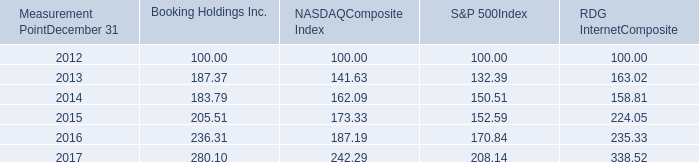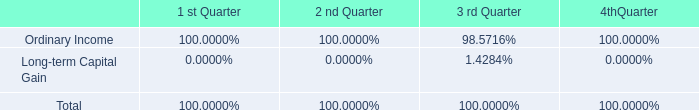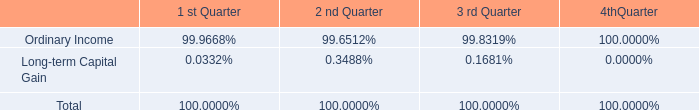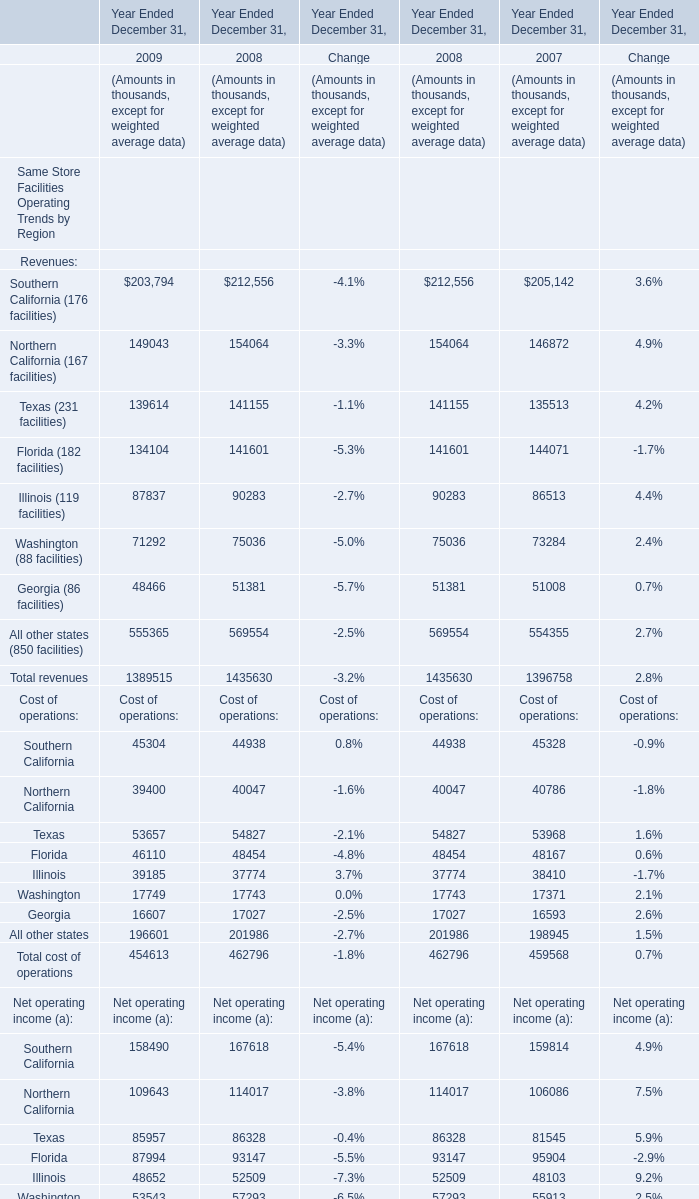What's the average of Southern California in 2008 and 2009 ? 
Computations: ((45304 + 44938) / 2)
Answer: 45121.0. 